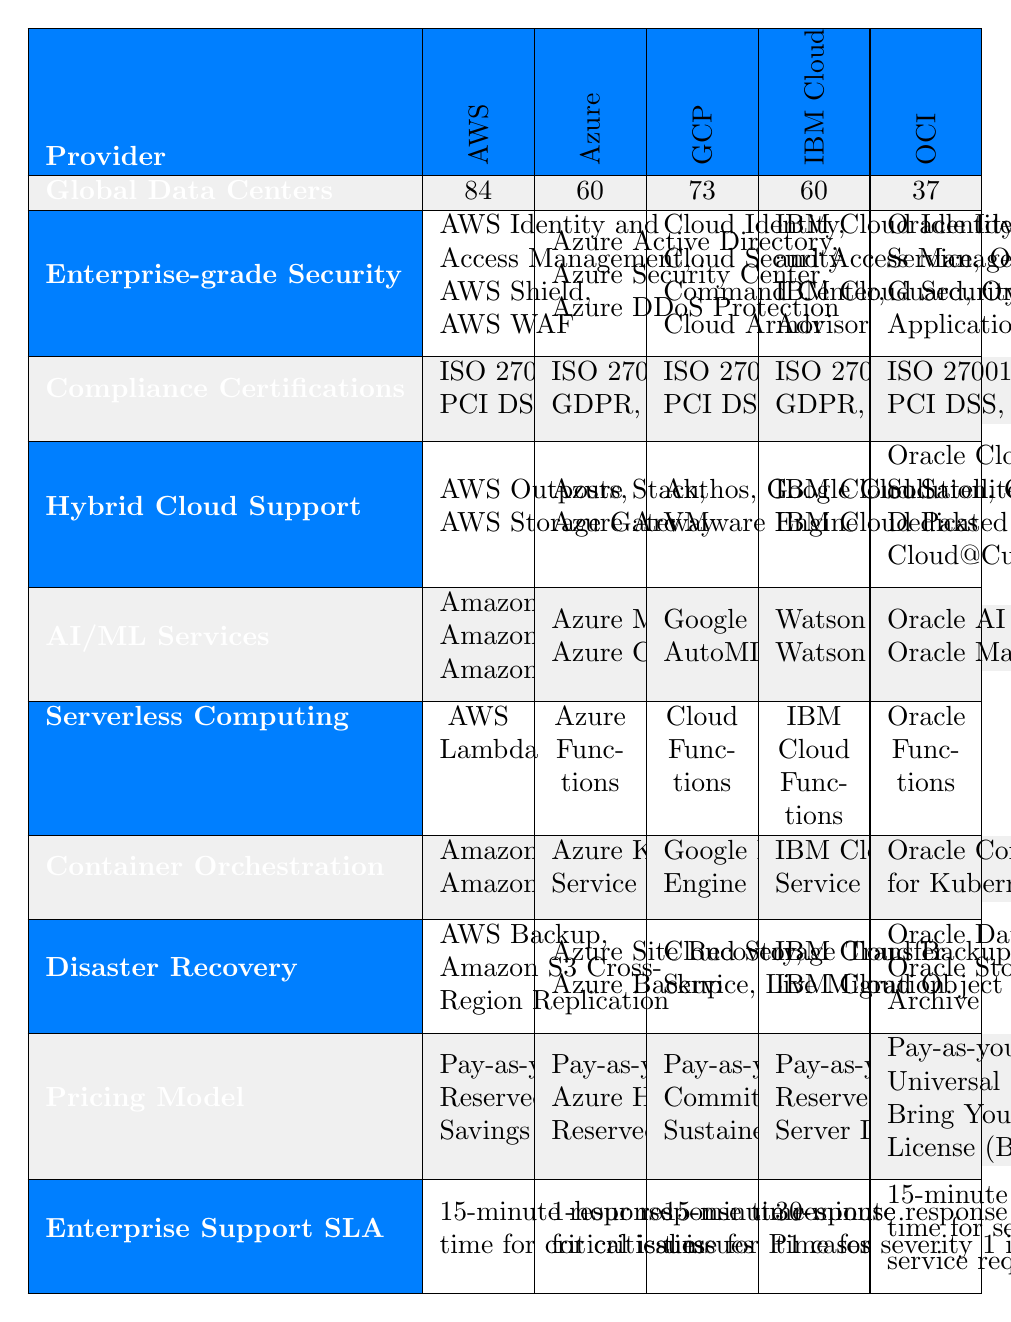What is the total number of global data centers among all the providers? The global data centers for each provider are as follows: AWS has 84, Azure has 60, GCP has 73, IBM Cloud has 60, and OCI has 37. Adding these together: 84 + 60 + 73 + 60 + 37 = 314.
Answer: 314 Which cloud provider has the most comprehensive compliance certifications? AWS, GCP, IBM Cloud, and OCI have ISO 27001, SOC 2, and PCI DSS, while Azure has ISO 27001, SOC 2, GDPR, and FedRAMP. Azure includes two additional certifications (GDPR and FedRAMP), making it the most comprehensive.
Answer: Azure Does IBM Cloud support a hybrid cloud solution? IBM Cloud supports hybrid cloud solutions with services like IBM Cloud Satellite and IBM Cloud Paks. Therefore, the statement is true.
Answer: Yes Which cloud provider offers the quickest response time for enterprise support issues? AWS and GCP have a 15-minute response time, while Azure has a 1-hour response time and IBM Cloud has 30 minutes. Since AWS and GCP both have the quickest response times, we can ascertain AWS holds a marginal advantage.
Answer: AWS and GCP What is the average number of global data centers across all providers? The total number of global data centers is 314 (as calculated previously). There are 5 providers, so the average is calculated as 314 / 5 = 62.8.
Answer: 62.8 How many providers offer serverless computing services? All five providers listed: AWS, Azure, GCP, IBM Cloud, and OCI have serverless computing solutions, thus confirming that all offer this feature.
Answer: Yes Which provider has the fewest global data centers, and how many do they have? OCI has the fewest global data centers at 37. Hence, the provider with the least count is OCI.
Answer: OCI, 37 How does the disaster recovery support of GCP compare to that of Azure? GCP offers Cloud Storage Transfer Service and Live Migration for disaster recovery, while Azure provides Azure Site Recovery and Azure Backup. Both providers have strong disaster recovery options, but GCP appears to focus more on migration solutions.
Answer: Both are strong, GCP focuses on migration Which cloud provider provides the most extensive AI/ML services? AWS offers Amazon SageMaker, Amazon Rekognition, and Amazon Lex; Azure has Azure Machine Learning and Azure Cognitive Services; GCP features Google Cloud AI Platform, AutoML, and TensorFlow; IBM Cloud includes Watson Studio and Watson Machine Learning; OCI lists Oracle AI Services and Oracle Machine Learning. AWS has the most services with three distinct offerings.
Answer: AWS 